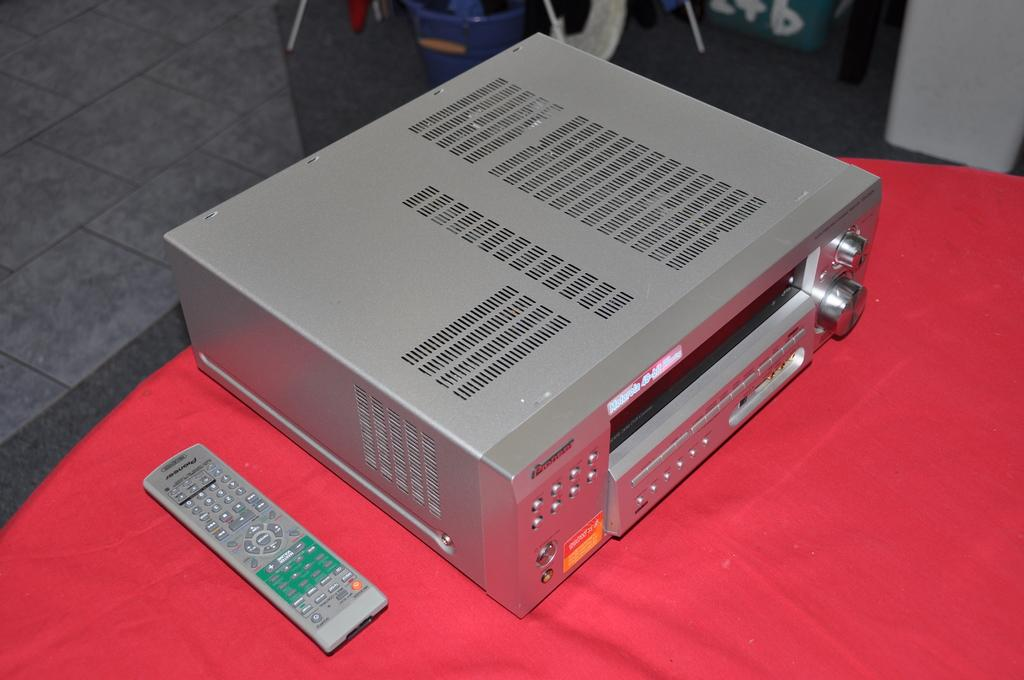<image>
Relay a brief, clear account of the picture shown. A Pioneer brand remote control sits on a table next to a professional grade video tape machine. 